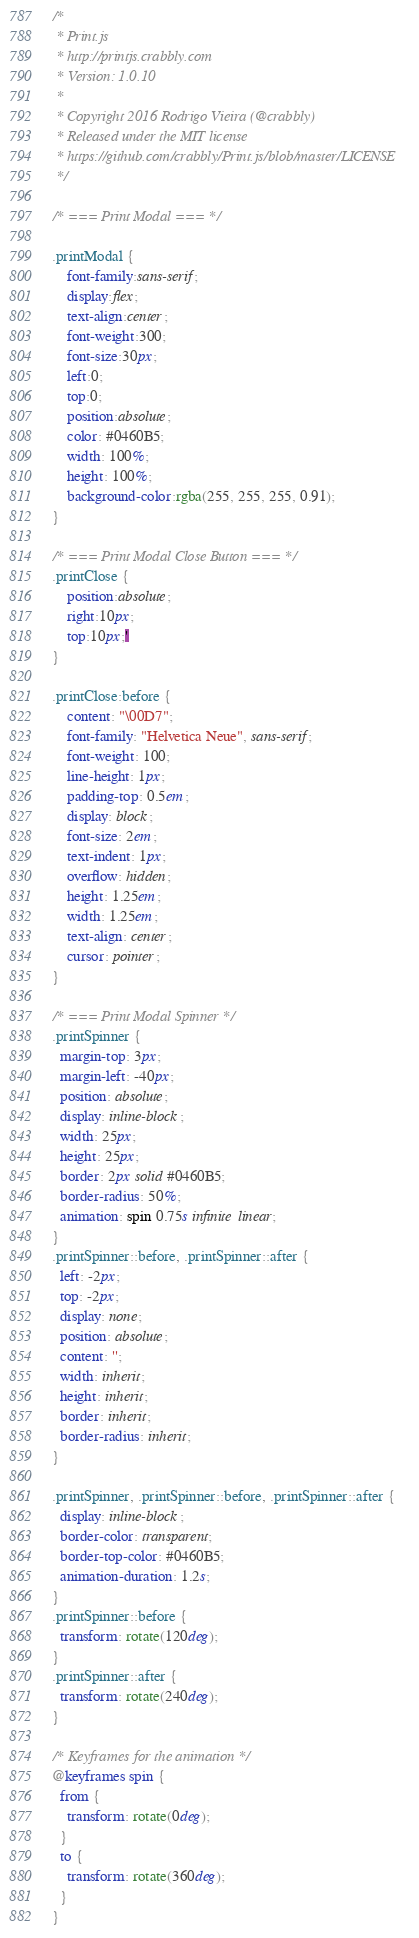Convert code to text. <code><loc_0><loc_0><loc_500><loc_500><_CSS_>/*
 * Print.js
 * http://printjs.crabbly.com
 * Version: 1.0.10
 *
 * Copyright 2016 Rodrigo Vieira (@crabbly)
 * Released under the MIT license
 * https://github.com/crabbly/Print.js/blob/master/LICENSE
 */

/* === Print Modal === */

.printModal {
    font-family:sans-serif;
    display:flex;
    text-align:center;
    font-weight:300;
    font-size:30px;
    left:0;
    top:0;
    position:absolute;
    color: #0460B5;
    width: 100%;
    height: 100%;
    background-color:rgba(255, 255, 255, 0.91);
}

/* === Print Modal Close Button === */
.printClose {
    position:absolute;
    right:10px;
    top:10px;'
}

.printClose:before {
    content: "\00D7";
    font-family: "Helvetica Neue", sans-serif;
    font-weight: 100;
    line-height: 1px;
    padding-top: 0.5em;
    display: block;
    font-size: 2em;
    text-indent: 1px;
    overflow: hidden;
    height: 1.25em;
    width: 1.25em;
    text-align: center;
    cursor: pointer;
}

/* === Print Modal Spinner */
.printSpinner {
  margin-top: 3px;
  margin-left: -40px;
  position: absolute;
  display: inline-block;
  width: 25px;
  height: 25px;
  border: 2px solid #0460B5;
  border-radius: 50%;
  animation: spin 0.75s infinite linear;
}
.printSpinner::before, .printSpinner::after {
  left: -2px;
  top: -2px;
  display: none;
  position: absolute;
  content: '';
  width: inherit;
  height: inherit;
  border: inherit;
  border-radius: inherit;
}

.printSpinner, .printSpinner::before, .printSpinner::after {
  display: inline-block;
  border-color: transparent;
  border-top-color: #0460B5;
  animation-duration: 1.2s;
}
.printSpinner::before {
  transform: rotate(120deg);
}
.printSpinner::after {
  transform: rotate(240deg);
}

/* Keyframes for the animation */
@keyframes spin {
  from {
    transform: rotate(0deg);
  }
  to {
    transform: rotate(360deg);
  }
}

</code> 